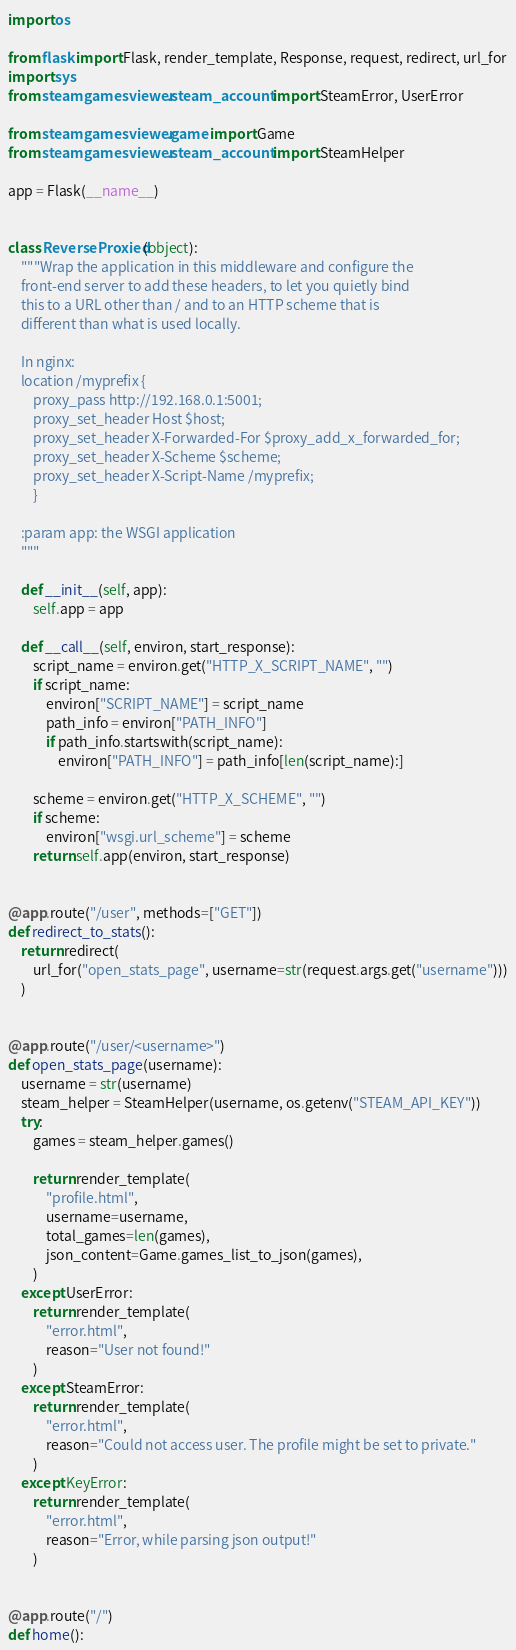<code> <loc_0><loc_0><loc_500><loc_500><_Python_>import os

from flask import Flask, render_template, Response, request, redirect, url_for
import sys
from steamgamesviewer.steam_account import SteamError, UserError

from steamgamesviewer.game import Game
from steamgamesviewer.steam_account import SteamHelper

app = Flask(__name__)


class ReverseProxied(object):
    """Wrap the application in this middleware and configure the
    front-end server to add these headers, to let you quietly bind
    this to a URL other than / and to an HTTP scheme that is
    different than what is used locally.

    In nginx:
    location /myprefix {
        proxy_pass http://192.168.0.1:5001;
        proxy_set_header Host $host;
        proxy_set_header X-Forwarded-For $proxy_add_x_forwarded_for;
        proxy_set_header X-Scheme $scheme;
        proxy_set_header X-Script-Name /myprefix;
        }

    :param app: the WSGI application
    """

    def __init__(self, app):
        self.app = app

    def __call__(self, environ, start_response):
        script_name = environ.get("HTTP_X_SCRIPT_NAME", "")
        if script_name:
            environ["SCRIPT_NAME"] = script_name
            path_info = environ["PATH_INFO"]
            if path_info.startswith(script_name):
                environ["PATH_INFO"] = path_info[len(script_name):]

        scheme = environ.get("HTTP_X_SCHEME", "")
        if scheme:
            environ["wsgi.url_scheme"] = scheme
        return self.app(environ, start_response)


@app.route("/user", methods=["GET"])
def redirect_to_stats():
    return redirect(
        url_for("open_stats_page", username=str(request.args.get("username")))
    )


@app.route("/user/<username>")
def open_stats_page(username):
    username = str(username)
    steam_helper = SteamHelper(username, os.getenv("STEAM_API_KEY"))
    try:
        games = steam_helper.games()

        return render_template(
            "profile.html",
            username=username,
            total_games=len(games),
            json_content=Game.games_list_to_json(games),
        )
    except UserError:
        return render_template(
            "error.html",
            reason="User not found!"
        )
    except SteamError:
        return render_template(
            "error.html",
            reason="Could not access user. The profile might be set to private."
        )
    except KeyError:
        return render_template(
            "error.html",
            reason="Error, while parsing json output!"
        )


@app.route("/")
def home():</code> 